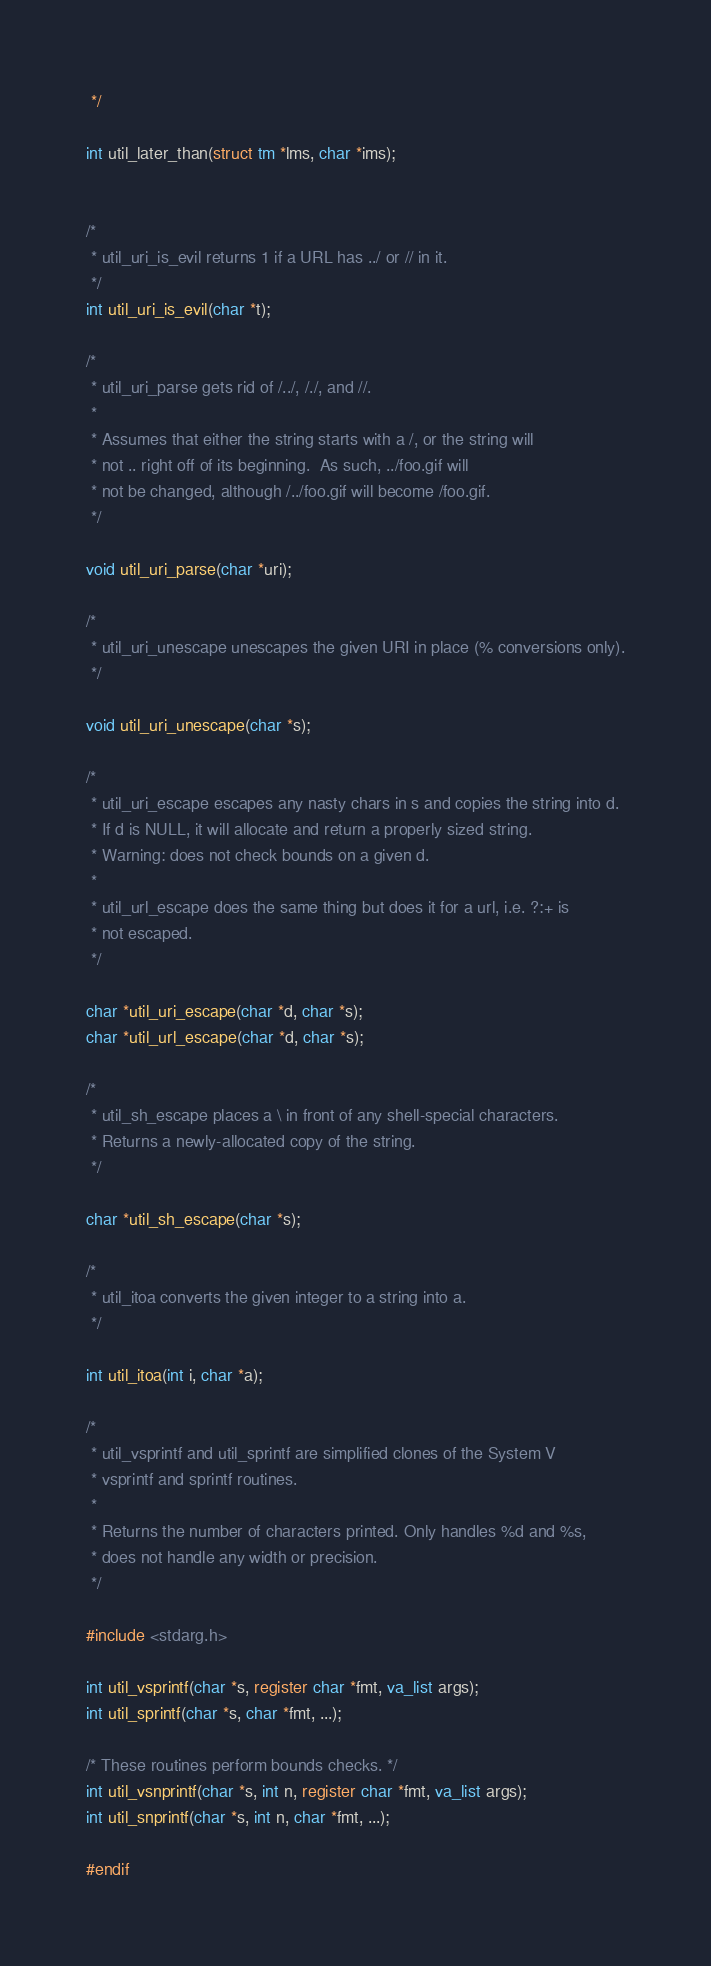<code> <loc_0><loc_0><loc_500><loc_500><_C_> */

int util_later_than(struct tm *lms, char *ims);


/*
 * util_uri_is_evil returns 1 if a URL has ../ or // in it.
 */
int util_uri_is_evil(char *t);

/*
 * util_uri_parse gets rid of /../, /./, and //.
 *
 * Assumes that either the string starts with a /, or the string will
 * not .. right off of its beginning.  As such, ../foo.gif will
 * not be changed, although /../foo.gif will become /foo.gif.
 */

void util_uri_parse(char *uri);

/*
 * util_uri_unescape unescapes the given URI in place (% conversions only).
 */

void util_uri_unescape(char *s);

/*
 * util_uri_escape escapes any nasty chars in s and copies the string into d.
 * If d is NULL, it will allocate and return a properly sized string.
 * Warning: does not check bounds on a given d.
 *
 * util_url_escape does the same thing but does it for a url, i.e. ?:+ is
 * not escaped.
 */

char *util_uri_escape(char *d, char *s);
char *util_url_escape(char *d, char *s);

/*
 * util_sh_escape places a \ in front of any shell-special characters.
 * Returns a newly-allocated copy of the string.
 */

char *util_sh_escape(char *s);

/*
 * util_itoa converts the given integer to a string into a.
 */

int util_itoa(int i, char *a);

/*
 * util_vsprintf and util_sprintf are simplified clones of the System V
 * vsprintf and sprintf routines.
 *
 * Returns the number of characters printed. Only handles %d and %s,
 * does not handle any width or precision.
 */

#include <stdarg.h>

int util_vsprintf(char *s, register char *fmt, va_list args);
int util_sprintf(char *s, char *fmt, ...);

/* These routines perform bounds checks. */
int util_vsnprintf(char *s, int n, register char *fmt, va_list args);
int util_snprintf(char *s, int n, char *fmt, ...);

#endif
</code> 